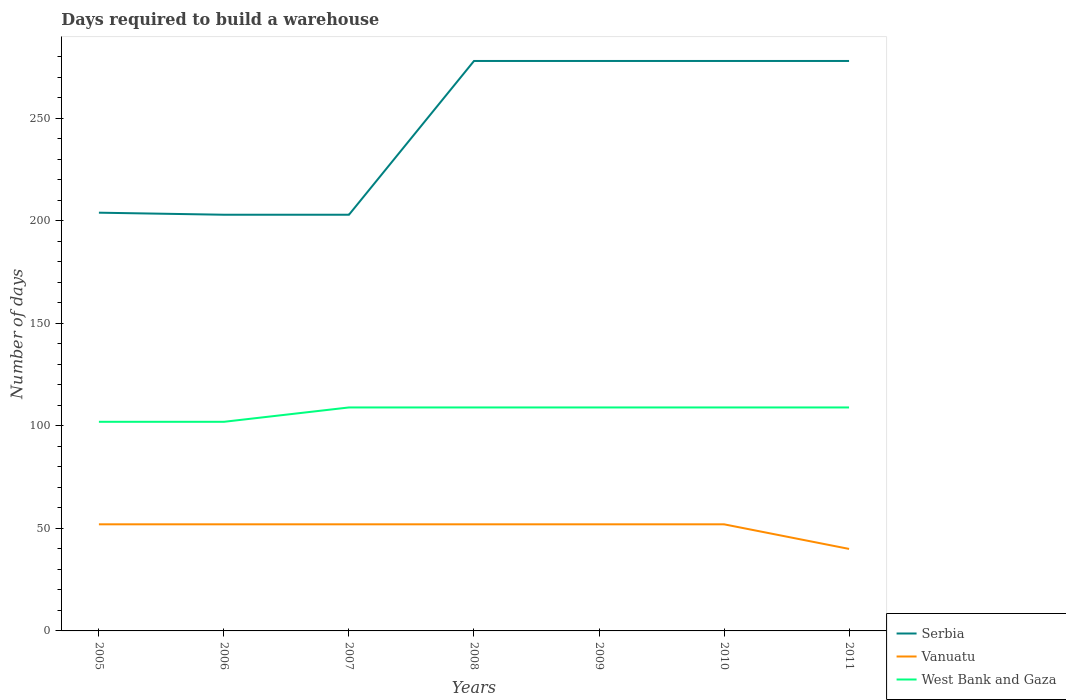Is the number of lines equal to the number of legend labels?
Your response must be concise. Yes. Across all years, what is the maximum days required to build a warehouse in in Serbia?
Provide a succinct answer. 203. In which year was the days required to build a warehouse in in West Bank and Gaza maximum?
Offer a terse response. 2005. What is the total days required to build a warehouse in in West Bank and Gaza in the graph?
Ensure brevity in your answer.  -7. What is the difference between the highest and the second highest days required to build a warehouse in in West Bank and Gaza?
Provide a short and direct response. 7. Is the days required to build a warehouse in in Serbia strictly greater than the days required to build a warehouse in in West Bank and Gaza over the years?
Offer a terse response. No. How many years are there in the graph?
Give a very brief answer. 7. Are the values on the major ticks of Y-axis written in scientific E-notation?
Your response must be concise. No. Does the graph contain grids?
Your response must be concise. No. Where does the legend appear in the graph?
Provide a short and direct response. Bottom right. How are the legend labels stacked?
Provide a short and direct response. Vertical. What is the title of the graph?
Provide a short and direct response. Days required to build a warehouse. Does "New Caledonia" appear as one of the legend labels in the graph?
Your answer should be compact. No. What is the label or title of the X-axis?
Offer a terse response. Years. What is the label or title of the Y-axis?
Your answer should be very brief. Number of days. What is the Number of days of Serbia in 2005?
Provide a short and direct response. 204. What is the Number of days of Vanuatu in 2005?
Provide a succinct answer. 52. What is the Number of days of West Bank and Gaza in 2005?
Provide a short and direct response. 102. What is the Number of days of Serbia in 2006?
Provide a succinct answer. 203. What is the Number of days in Vanuatu in 2006?
Your answer should be compact. 52. What is the Number of days in West Bank and Gaza in 2006?
Your answer should be very brief. 102. What is the Number of days of Serbia in 2007?
Your response must be concise. 203. What is the Number of days of West Bank and Gaza in 2007?
Ensure brevity in your answer.  109. What is the Number of days in Serbia in 2008?
Your answer should be very brief. 278. What is the Number of days in Vanuatu in 2008?
Your answer should be very brief. 52. What is the Number of days of West Bank and Gaza in 2008?
Offer a very short reply. 109. What is the Number of days in Serbia in 2009?
Offer a terse response. 278. What is the Number of days in Vanuatu in 2009?
Keep it short and to the point. 52. What is the Number of days in West Bank and Gaza in 2009?
Give a very brief answer. 109. What is the Number of days of Serbia in 2010?
Offer a terse response. 278. What is the Number of days in West Bank and Gaza in 2010?
Offer a terse response. 109. What is the Number of days of Serbia in 2011?
Offer a terse response. 278. What is the Number of days of Vanuatu in 2011?
Provide a short and direct response. 40. What is the Number of days in West Bank and Gaza in 2011?
Give a very brief answer. 109. Across all years, what is the maximum Number of days of Serbia?
Keep it short and to the point. 278. Across all years, what is the maximum Number of days of West Bank and Gaza?
Provide a succinct answer. 109. Across all years, what is the minimum Number of days in Serbia?
Your answer should be very brief. 203. Across all years, what is the minimum Number of days of Vanuatu?
Offer a terse response. 40. Across all years, what is the minimum Number of days of West Bank and Gaza?
Make the answer very short. 102. What is the total Number of days of Serbia in the graph?
Keep it short and to the point. 1722. What is the total Number of days of Vanuatu in the graph?
Make the answer very short. 352. What is the total Number of days of West Bank and Gaza in the graph?
Make the answer very short. 749. What is the difference between the Number of days in Serbia in 2005 and that in 2006?
Offer a terse response. 1. What is the difference between the Number of days of Vanuatu in 2005 and that in 2006?
Ensure brevity in your answer.  0. What is the difference between the Number of days in West Bank and Gaza in 2005 and that in 2006?
Provide a short and direct response. 0. What is the difference between the Number of days of Serbia in 2005 and that in 2008?
Ensure brevity in your answer.  -74. What is the difference between the Number of days of Serbia in 2005 and that in 2009?
Provide a succinct answer. -74. What is the difference between the Number of days of Vanuatu in 2005 and that in 2009?
Keep it short and to the point. 0. What is the difference between the Number of days in Serbia in 2005 and that in 2010?
Provide a succinct answer. -74. What is the difference between the Number of days of Vanuatu in 2005 and that in 2010?
Offer a very short reply. 0. What is the difference between the Number of days of West Bank and Gaza in 2005 and that in 2010?
Offer a very short reply. -7. What is the difference between the Number of days of Serbia in 2005 and that in 2011?
Ensure brevity in your answer.  -74. What is the difference between the Number of days in West Bank and Gaza in 2005 and that in 2011?
Provide a succinct answer. -7. What is the difference between the Number of days of Serbia in 2006 and that in 2007?
Give a very brief answer. 0. What is the difference between the Number of days of Serbia in 2006 and that in 2008?
Provide a short and direct response. -75. What is the difference between the Number of days of Vanuatu in 2006 and that in 2008?
Provide a short and direct response. 0. What is the difference between the Number of days in Serbia in 2006 and that in 2009?
Your answer should be compact. -75. What is the difference between the Number of days of Serbia in 2006 and that in 2010?
Your answer should be very brief. -75. What is the difference between the Number of days of Vanuatu in 2006 and that in 2010?
Your answer should be very brief. 0. What is the difference between the Number of days of Serbia in 2006 and that in 2011?
Your response must be concise. -75. What is the difference between the Number of days in Vanuatu in 2006 and that in 2011?
Keep it short and to the point. 12. What is the difference between the Number of days of West Bank and Gaza in 2006 and that in 2011?
Offer a terse response. -7. What is the difference between the Number of days of Serbia in 2007 and that in 2008?
Your answer should be very brief. -75. What is the difference between the Number of days in Vanuatu in 2007 and that in 2008?
Provide a short and direct response. 0. What is the difference between the Number of days of Serbia in 2007 and that in 2009?
Offer a very short reply. -75. What is the difference between the Number of days in Serbia in 2007 and that in 2010?
Offer a very short reply. -75. What is the difference between the Number of days in West Bank and Gaza in 2007 and that in 2010?
Offer a terse response. 0. What is the difference between the Number of days in Serbia in 2007 and that in 2011?
Ensure brevity in your answer.  -75. What is the difference between the Number of days of Serbia in 2008 and that in 2009?
Offer a very short reply. 0. What is the difference between the Number of days in West Bank and Gaza in 2008 and that in 2009?
Provide a succinct answer. 0. What is the difference between the Number of days in Serbia in 2008 and that in 2010?
Your answer should be very brief. 0. What is the difference between the Number of days of Vanuatu in 2008 and that in 2010?
Offer a terse response. 0. What is the difference between the Number of days in Serbia in 2008 and that in 2011?
Offer a very short reply. 0. What is the difference between the Number of days in West Bank and Gaza in 2008 and that in 2011?
Keep it short and to the point. 0. What is the difference between the Number of days in West Bank and Gaza in 2009 and that in 2010?
Provide a short and direct response. 0. What is the difference between the Number of days of Serbia in 2009 and that in 2011?
Your answer should be very brief. 0. What is the difference between the Number of days in Vanuatu in 2009 and that in 2011?
Your answer should be very brief. 12. What is the difference between the Number of days of West Bank and Gaza in 2009 and that in 2011?
Your answer should be very brief. 0. What is the difference between the Number of days of Vanuatu in 2010 and that in 2011?
Offer a terse response. 12. What is the difference between the Number of days in Serbia in 2005 and the Number of days in Vanuatu in 2006?
Your answer should be very brief. 152. What is the difference between the Number of days in Serbia in 2005 and the Number of days in West Bank and Gaza in 2006?
Provide a short and direct response. 102. What is the difference between the Number of days in Vanuatu in 2005 and the Number of days in West Bank and Gaza in 2006?
Provide a short and direct response. -50. What is the difference between the Number of days of Serbia in 2005 and the Number of days of Vanuatu in 2007?
Your answer should be compact. 152. What is the difference between the Number of days in Vanuatu in 2005 and the Number of days in West Bank and Gaza in 2007?
Offer a terse response. -57. What is the difference between the Number of days in Serbia in 2005 and the Number of days in Vanuatu in 2008?
Provide a succinct answer. 152. What is the difference between the Number of days in Serbia in 2005 and the Number of days in West Bank and Gaza in 2008?
Ensure brevity in your answer.  95. What is the difference between the Number of days in Vanuatu in 2005 and the Number of days in West Bank and Gaza in 2008?
Your response must be concise. -57. What is the difference between the Number of days in Serbia in 2005 and the Number of days in Vanuatu in 2009?
Keep it short and to the point. 152. What is the difference between the Number of days of Vanuatu in 2005 and the Number of days of West Bank and Gaza in 2009?
Provide a short and direct response. -57. What is the difference between the Number of days in Serbia in 2005 and the Number of days in Vanuatu in 2010?
Your response must be concise. 152. What is the difference between the Number of days in Vanuatu in 2005 and the Number of days in West Bank and Gaza in 2010?
Offer a terse response. -57. What is the difference between the Number of days of Serbia in 2005 and the Number of days of Vanuatu in 2011?
Offer a very short reply. 164. What is the difference between the Number of days of Vanuatu in 2005 and the Number of days of West Bank and Gaza in 2011?
Offer a terse response. -57. What is the difference between the Number of days of Serbia in 2006 and the Number of days of Vanuatu in 2007?
Your response must be concise. 151. What is the difference between the Number of days of Serbia in 2006 and the Number of days of West Bank and Gaza in 2007?
Your answer should be compact. 94. What is the difference between the Number of days in Vanuatu in 2006 and the Number of days in West Bank and Gaza in 2007?
Your response must be concise. -57. What is the difference between the Number of days in Serbia in 2006 and the Number of days in Vanuatu in 2008?
Offer a very short reply. 151. What is the difference between the Number of days of Serbia in 2006 and the Number of days of West Bank and Gaza in 2008?
Your answer should be very brief. 94. What is the difference between the Number of days in Vanuatu in 2006 and the Number of days in West Bank and Gaza in 2008?
Give a very brief answer. -57. What is the difference between the Number of days in Serbia in 2006 and the Number of days in Vanuatu in 2009?
Your answer should be compact. 151. What is the difference between the Number of days in Serbia in 2006 and the Number of days in West Bank and Gaza in 2009?
Provide a short and direct response. 94. What is the difference between the Number of days in Vanuatu in 2006 and the Number of days in West Bank and Gaza in 2009?
Offer a terse response. -57. What is the difference between the Number of days of Serbia in 2006 and the Number of days of Vanuatu in 2010?
Your response must be concise. 151. What is the difference between the Number of days in Serbia in 2006 and the Number of days in West Bank and Gaza in 2010?
Keep it short and to the point. 94. What is the difference between the Number of days in Vanuatu in 2006 and the Number of days in West Bank and Gaza in 2010?
Offer a very short reply. -57. What is the difference between the Number of days of Serbia in 2006 and the Number of days of Vanuatu in 2011?
Your answer should be very brief. 163. What is the difference between the Number of days in Serbia in 2006 and the Number of days in West Bank and Gaza in 2011?
Your answer should be compact. 94. What is the difference between the Number of days in Vanuatu in 2006 and the Number of days in West Bank and Gaza in 2011?
Provide a short and direct response. -57. What is the difference between the Number of days of Serbia in 2007 and the Number of days of Vanuatu in 2008?
Give a very brief answer. 151. What is the difference between the Number of days in Serbia in 2007 and the Number of days in West Bank and Gaza in 2008?
Provide a succinct answer. 94. What is the difference between the Number of days of Vanuatu in 2007 and the Number of days of West Bank and Gaza in 2008?
Offer a very short reply. -57. What is the difference between the Number of days in Serbia in 2007 and the Number of days in Vanuatu in 2009?
Make the answer very short. 151. What is the difference between the Number of days in Serbia in 2007 and the Number of days in West Bank and Gaza in 2009?
Give a very brief answer. 94. What is the difference between the Number of days in Vanuatu in 2007 and the Number of days in West Bank and Gaza in 2009?
Provide a short and direct response. -57. What is the difference between the Number of days in Serbia in 2007 and the Number of days in Vanuatu in 2010?
Provide a short and direct response. 151. What is the difference between the Number of days in Serbia in 2007 and the Number of days in West Bank and Gaza in 2010?
Offer a very short reply. 94. What is the difference between the Number of days in Vanuatu in 2007 and the Number of days in West Bank and Gaza in 2010?
Give a very brief answer. -57. What is the difference between the Number of days in Serbia in 2007 and the Number of days in Vanuatu in 2011?
Your answer should be very brief. 163. What is the difference between the Number of days of Serbia in 2007 and the Number of days of West Bank and Gaza in 2011?
Give a very brief answer. 94. What is the difference between the Number of days in Vanuatu in 2007 and the Number of days in West Bank and Gaza in 2011?
Keep it short and to the point. -57. What is the difference between the Number of days in Serbia in 2008 and the Number of days in Vanuatu in 2009?
Offer a terse response. 226. What is the difference between the Number of days in Serbia in 2008 and the Number of days in West Bank and Gaza in 2009?
Give a very brief answer. 169. What is the difference between the Number of days in Vanuatu in 2008 and the Number of days in West Bank and Gaza in 2009?
Give a very brief answer. -57. What is the difference between the Number of days of Serbia in 2008 and the Number of days of Vanuatu in 2010?
Offer a very short reply. 226. What is the difference between the Number of days in Serbia in 2008 and the Number of days in West Bank and Gaza in 2010?
Offer a very short reply. 169. What is the difference between the Number of days in Vanuatu in 2008 and the Number of days in West Bank and Gaza in 2010?
Keep it short and to the point. -57. What is the difference between the Number of days in Serbia in 2008 and the Number of days in Vanuatu in 2011?
Your response must be concise. 238. What is the difference between the Number of days of Serbia in 2008 and the Number of days of West Bank and Gaza in 2011?
Ensure brevity in your answer.  169. What is the difference between the Number of days in Vanuatu in 2008 and the Number of days in West Bank and Gaza in 2011?
Keep it short and to the point. -57. What is the difference between the Number of days in Serbia in 2009 and the Number of days in Vanuatu in 2010?
Provide a short and direct response. 226. What is the difference between the Number of days of Serbia in 2009 and the Number of days of West Bank and Gaza in 2010?
Ensure brevity in your answer.  169. What is the difference between the Number of days in Vanuatu in 2009 and the Number of days in West Bank and Gaza in 2010?
Offer a terse response. -57. What is the difference between the Number of days in Serbia in 2009 and the Number of days in Vanuatu in 2011?
Offer a very short reply. 238. What is the difference between the Number of days of Serbia in 2009 and the Number of days of West Bank and Gaza in 2011?
Your answer should be compact. 169. What is the difference between the Number of days of Vanuatu in 2009 and the Number of days of West Bank and Gaza in 2011?
Keep it short and to the point. -57. What is the difference between the Number of days of Serbia in 2010 and the Number of days of Vanuatu in 2011?
Ensure brevity in your answer.  238. What is the difference between the Number of days of Serbia in 2010 and the Number of days of West Bank and Gaza in 2011?
Give a very brief answer. 169. What is the difference between the Number of days of Vanuatu in 2010 and the Number of days of West Bank and Gaza in 2011?
Provide a short and direct response. -57. What is the average Number of days in Serbia per year?
Offer a very short reply. 246. What is the average Number of days in Vanuatu per year?
Your response must be concise. 50.29. What is the average Number of days in West Bank and Gaza per year?
Offer a terse response. 107. In the year 2005, what is the difference between the Number of days in Serbia and Number of days in Vanuatu?
Keep it short and to the point. 152. In the year 2005, what is the difference between the Number of days in Serbia and Number of days in West Bank and Gaza?
Make the answer very short. 102. In the year 2005, what is the difference between the Number of days of Vanuatu and Number of days of West Bank and Gaza?
Give a very brief answer. -50. In the year 2006, what is the difference between the Number of days of Serbia and Number of days of Vanuatu?
Your answer should be compact. 151. In the year 2006, what is the difference between the Number of days of Serbia and Number of days of West Bank and Gaza?
Offer a terse response. 101. In the year 2007, what is the difference between the Number of days of Serbia and Number of days of Vanuatu?
Provide a short and direct response. 151. In the year 2007, what is the difference between the Number of days in Serbia and Number of days in West Bank and Gaza?
Provide a succinct answer. 94. In the year 2007, what is the difference between the Number of days of Vanuatu and Number of days of West Bank and Gaza?
Make the answer very short. -57. In the year 2008, what is the difference between the Number of days in Serbia and Number of days in Vanuatu?
Provide a succinct answer. 226. In the year 2008, what is the difference between the Number of days of Serbia and Number of days of West Bank and Gaza?
Provide a short and direct response. 169. In the year 2008, what is the difference between the Number of days in Vanuatu and Number of days in West Bank and Gaza?
Provide a short and direct response. -57. In the year 2009, what is the difference between the Number of days in Serbia and Number of days in Vanuatu?
Make the answer very short. 226. In the year 2009, what is the difference between the Number of days in Serbia and Number of days in West Bank and Gaza?
Offer a terse response. 169. In the year 2009, what is the difference between the Number of days in Vanuatu and Number of days in West Bank and Gaza?
Offer a very short reply. -57. In the year 2010, what is the difference between the Number of days in Serbia and Number of days in Vanuatu?
Your response must be concise. 226. In the year 2010, what is the difference between the Number of days in Serbia and Number of days in West Bank and Gaza?
Ensure brevity in your answer.  169. In the year 2010, what is the difference between the Number of days in Vanuatu and Number of days in West Bank and Gaza?
Ensure brevity in your answer.  -57. In the year 2011, what is the difference between the Number of days in Serbia and Number of days in Vanuatu?
Give a very brief answer. 238. In the year 2011, what is the difference between the Number of days of Serbia and Number of days of West Bank and Gaza?
Make the answer very short. 169. In the year 2011, what is the difference between the Number of days of Vanuatu and Number of days of West Bank and Gaza?
Ensure brevity in your answer.  -69. What is the ratio of the Number of days of Vanuatu in 2005 to that in 2006?
Make the answer very short. 1. What is the ratio of the Number of days in West Bank and Gaza in 2005 to that in 2006?
Your answer should be compact. 1. What is the ratio of the Number of days in West Bank and Gaza in 2005 to that in 2007?
Make the answer very short. 0.94. What is the ratio of the Number of days of Serbia in 2005 to that in 2008?
Provide a succinct answer. 0.73. What is the ratio of the Number of days of Vanuatu in 2005 to that in 2008?
Your answer should be very brief. 1. What is the ratio of the Number of days in West Bank and Gaza in 2005 to that in 2008?
Make the answer very short. 0.94. What is the ratio of the Number of days of Serbia in 2005 to that in 2009?
Your answer should be very brief. 0.73. What is the ratio of the Number of days in Vanuatu in 2005 to that in 2009?
Ensure brevity in your answer.  1. What is the ratio of the Number of days of West Bank and Gaza in 2005 to that in 2009?
Provide a succinct answer. 0.94. What is the ratio of the Number of days of Serbia in 2005 to that in 2010?
Provide a short and direct response. 0.73. What is the ratio of the Number of days in West Bank and Gaza in 2005 to that in 2010?
Offer a terse response. 0.94. What is the ratio of the Number of days of Serbia in 2005 to that in 2011?
Provide a short and direct response. 0.73. What is the ratio of the Number of days in West Bank and Gaza in 2005 to that in 2011?
Your answer should be compact. 0.94. What is the ratio of the Number of days of Serbia in 2006 to that in 2007?
Offer a terse response. 1. What is the ratio of the Number of days of West Bank and Gaza in 2006 to that in 2007?
Give a very brief answer. 0.94. What is the ratio of the Number of days in Serbia in 2006 to that in 2008?
Your answer should be very brief. 0.73. What is the ratio of the Number of days of Vanuatu in 2006 to that in 2008?
Your answer should be compact. 1. What is the ratio of the Number of days of West Bank and Gaza in 2006 to that in 2008?
Your answer should be very brief. 0.94. What is the ratio of the Number of days in Serbia in 2006 to that in 2009?
Offer a terse response. 0.73. What is the ratio of the Number of days in Vanuatu in 2006 to that in 2009?
Offer a terse response. 1. What is the ratio of the Number of days of West Bank and Gaza in 2006 to that in 2009?
Your answer should be very brief. 0.94. What is the ratio of the Number of days in Serbia in 2006 to that in 2010?
Your answer should be compact. 0.73. What is the ratio of the Number of days of West Bank and Gaza in 2006 to that in 2010?
Make the answer very short. 0.94. What is the ratio of the Number of days of Serbia in 2006 to that in 2011?
Your answer should be compact. 0.73. What is the ratio of the Number of days of West Bank and Gaza in 2006 to that in 2011?
Give a very brief answer. 0.94. What is the ratio of the Number of days of Serbia in 2007 to that in 2008?
Make the answer very short. 0.73. What is the ratio of the Number of days in Vanuatu in 2007 to that in 2008?
Your answer should be very brief. 1. What is the ratio of the Number of days in Serbia in 2007 to that in 2009?
Offer a very short reply. 0.73. What is the ratio of the Number of days in Serbia in 2007 to that in 2010?
Your answer should be very brief. 0.73. What is the ratio of the Number of days of Vanuatu in 2007 to that in 2010?
Keep it short and to the point. 1. What is the ratio of the Number of days in West Bank and Gaza in 2007 to that in 2010?
Your answer should be very brief. 1. What is the ratio of the Number of days of Serbia in 2007 to that in 2011?
Ensure brevity in your answer.  0.73. What is the ratio of the Number of days of Vanuatu in 2008 to that in 2009?
Provide a short and direct response. 1. What is the ratio of the Number of days in West Bank and Gaza in 2008 to that in 2009?
Offer a terse response. 1. What is the ratio of the Number of days in Serbia in 2008 to that in 2010?
Provide a succinct answer. 1. What is the ratio of the Number of days of West Bank and Gaza in 2008 to that in 2011?
Keep it short and to the point. 1. What is the ratio of the Number of days of Serbia in 2009 to that in 2010?
Ensure brevity in your answer.  1. What is the ratio of the Number of days in Vanuatu in 2009 to that in 2010?
Your response must be concise. 1. What is the ratio of the Number of days in West Bank and Gaza in 2009 to that in 2010?
Provide a succinct answer. 1. What is the ratio of the Number of days of Serbia in 2009 to that in 2011?
Your answer should be compact. 1. What is the ratio of the Number of days in Vanuatu in 2009 to that in 2011?
Make the answer very short. 1.3. What is the ratio of the Number of days in West Bank and Gaza in 2009 to that in 2011?
Provide a short and direct response. 1. What is the difference between the highest and the second highest Number of days in Vanuatu?
Provide a succinct answer. 0. What is the difference between the highest and the lowest Number of days in Vanuatu?
Your response must be concise. 12. 